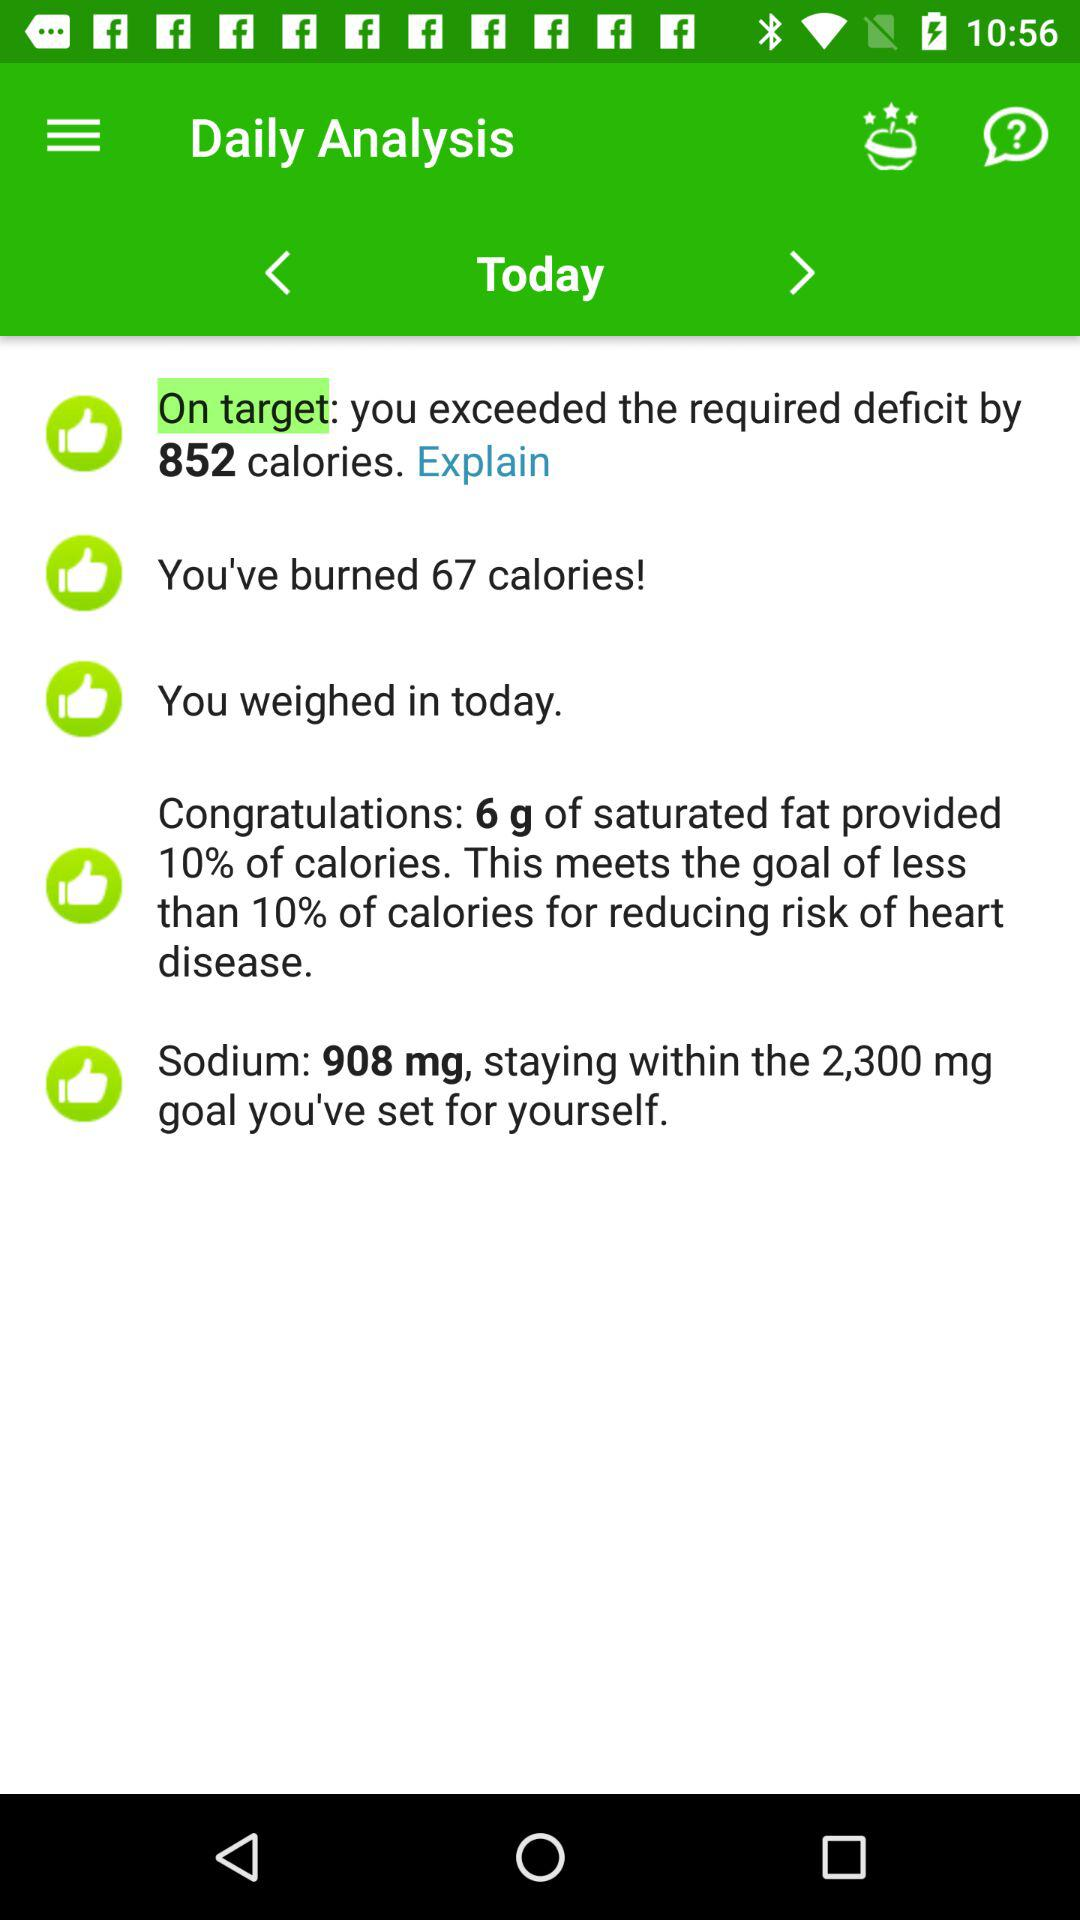How many calories are burned today? There are 67 calories burned today. 